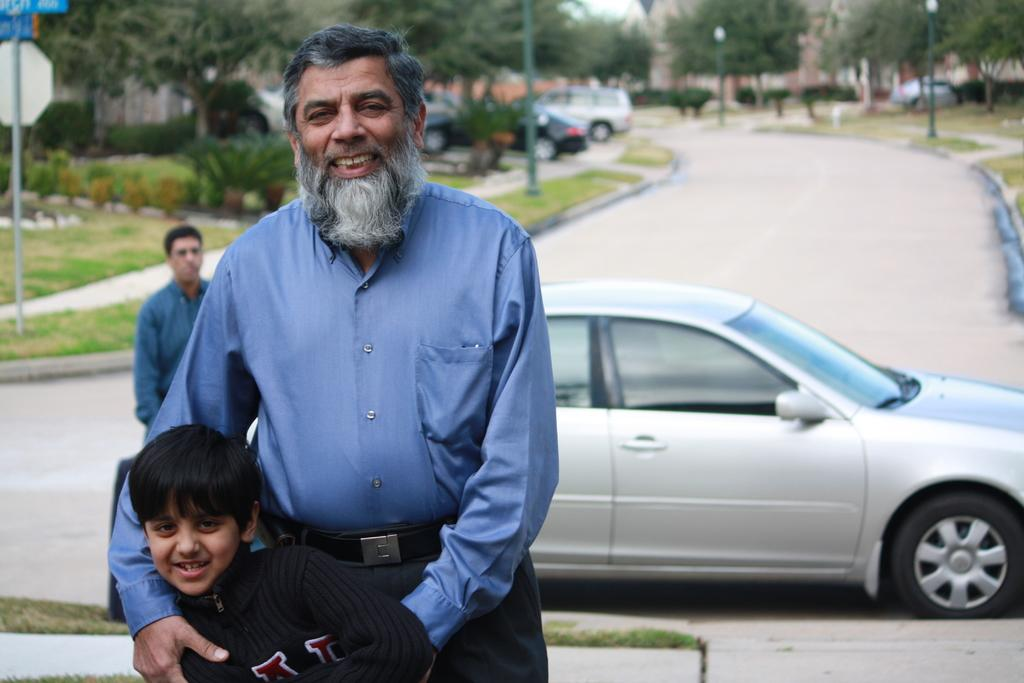How many people are standing in the image? There are two people standing in the image, a man and a boy. What else can be seen in the image besides the people? There are boards, poles, lights, plants, trees, and vehicles on the road in the image. What type of structures are present in the image? The boards and poles suggest that there might be some kind of structure or construction site in the image. What type of environment is depicted in the image? The presence of plants, trees, and vehicles on the road suggests that the image is set in an urban or suburban environment. Can you see any clover growing in the image? There is no clover visible in the image. Is the boy in the image using a skateboard? There is no skateboard present in the image. 